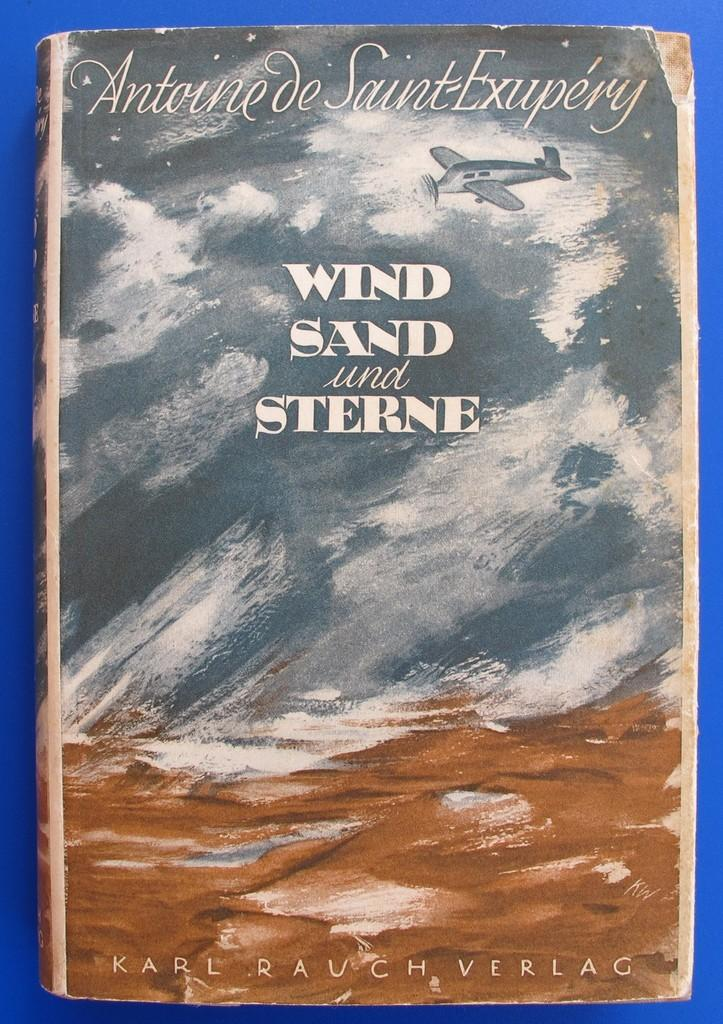Provide a one-sentence caption for the provided image. Cover of a book named Wind Sand and Sterne by Antoine de Saint-Exupery. 